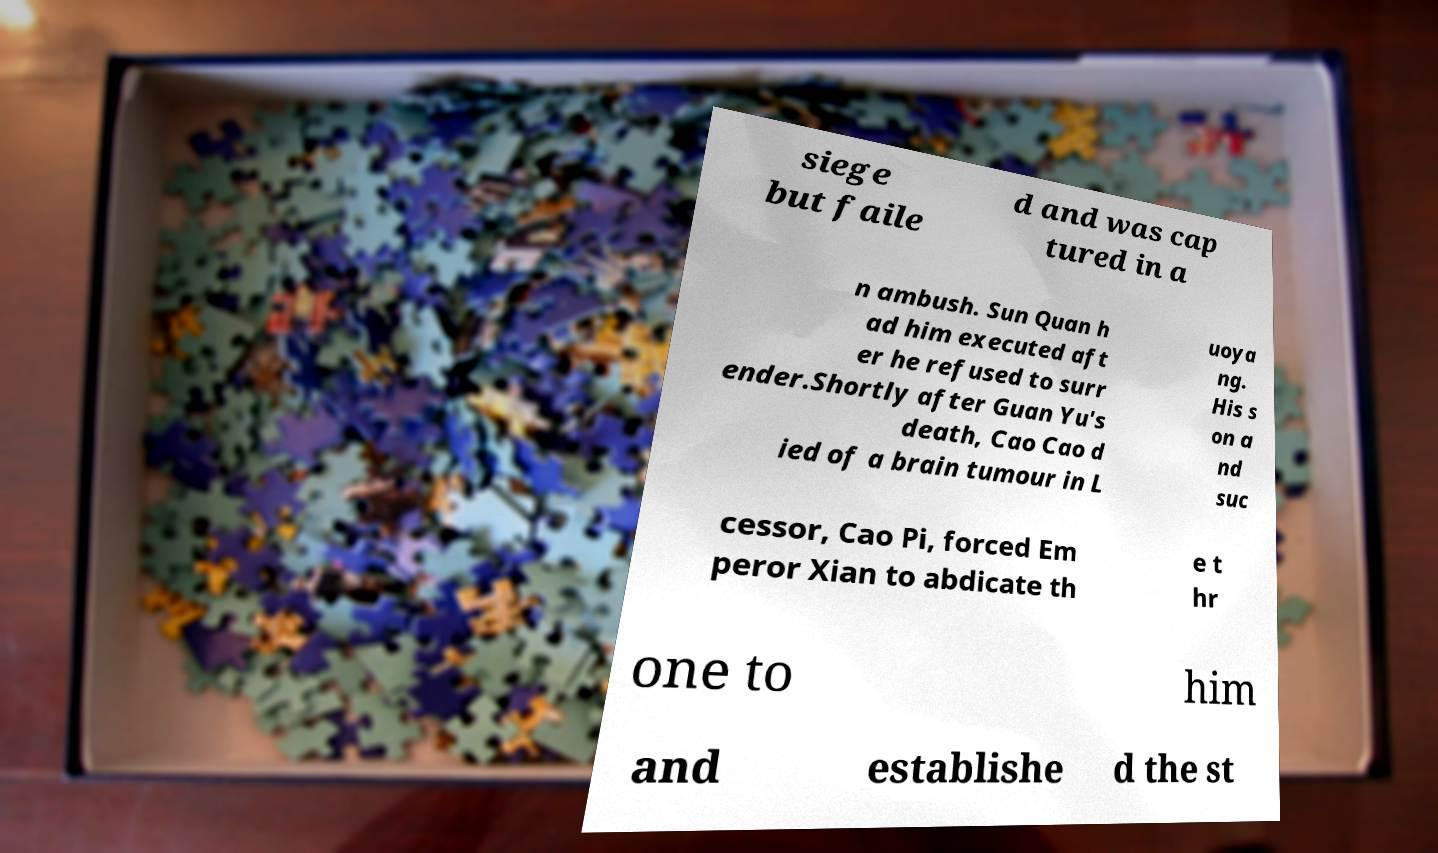For documentation purposes, I need the text within this image transcribed. Could you provide that? siege but faile d and was cap tured in a n ambush. Sun Quan h ad him executed aft er he refused to surr ender.Shortly after Guan Yu's death, Cao Cao d ied of a brain tumour in L uoya ng. His s on a nd suc cessor, Cao Pi, forced Em peror Xian to abdicate th e t hr one to him and establishe d the st 